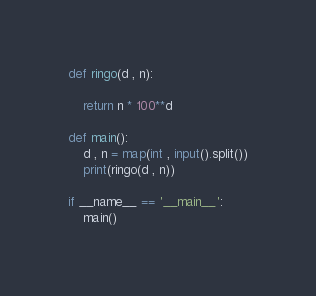Convert code to text. <code><loc_0><loc_0><loc_500><loc_500><_Python_>def ringo(d , n):

    return n * 100**d

def main():
    d , n = map(int , input().split())
    print(ringo(d , n))

if __name__ == '__main__':
    main()</code> 